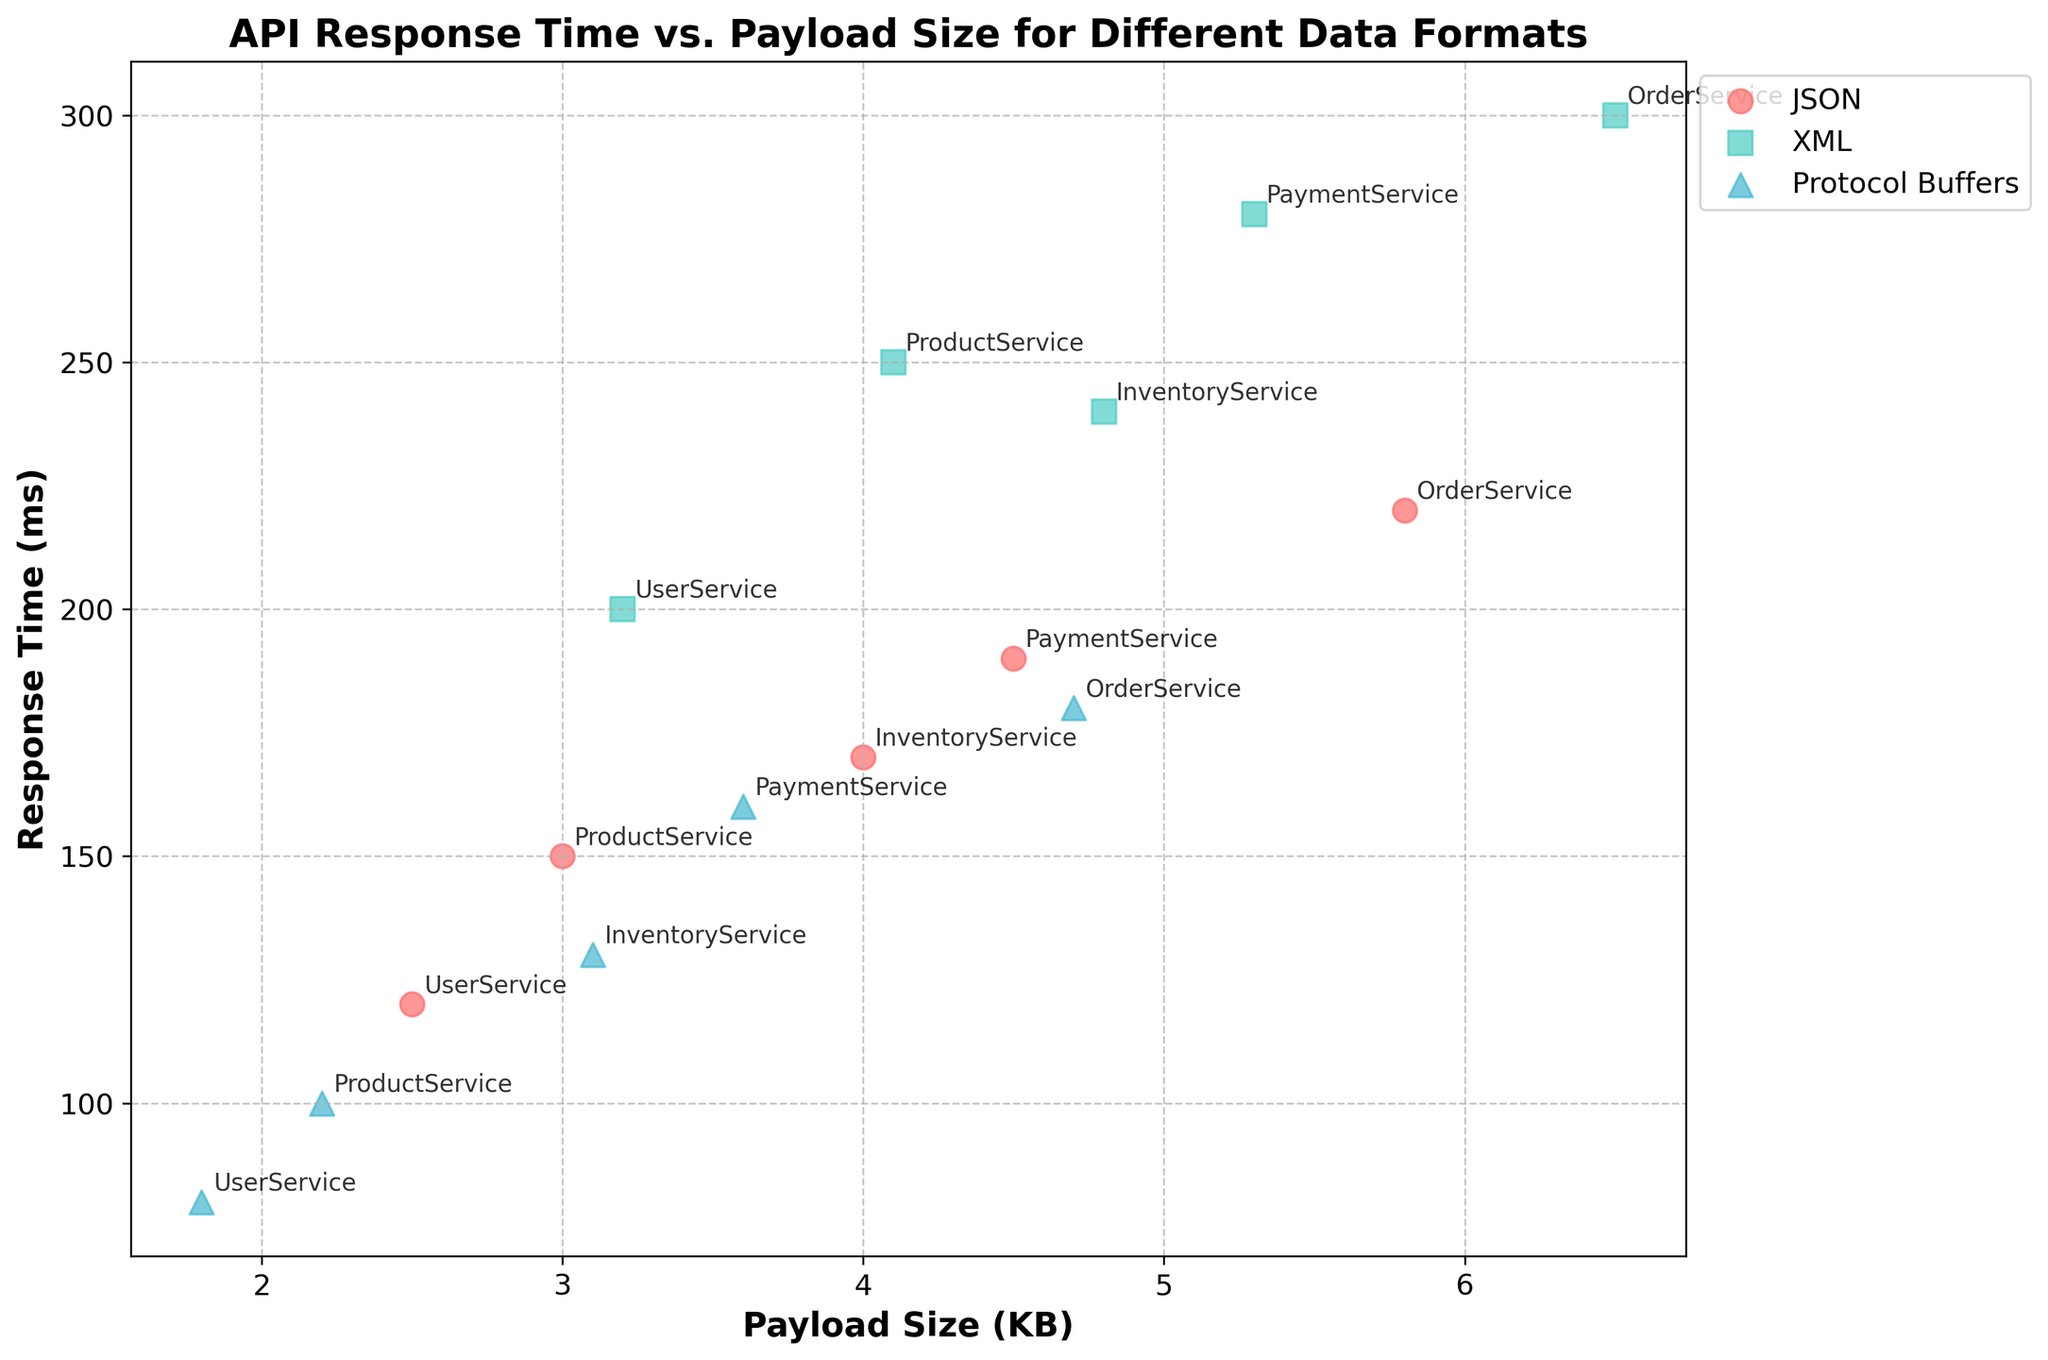What are the three different data formats represented in the figure? The legend in the figure indicates three different data formats represented by different colors and markers. These formats are JSON, XML, and Protocol Buffers.
Answer: JSON, XML, Protocol Buffers Which API has the smallest payload size for JSON format? Among the data points with the JSON format, the smallest payload size is located at UserService with a payload size of 2.5 KB.
Answer: UserService What is the trend between payload size and response time for each data format? By examining the scatter plot, we can observe the trend of response time as the payload size increases for each format. Generally, larger payload sizes correspond to higher response times, but this trend varies slightly across different data formats. JSON shows a noticeable increase, XML also increases with slightly steeper response times, and Protocol Buffers appear to have the least variation in response times.
Answer: Higher payload size tends to increase response time Which data format has the fastest response time for ProductService? The data points related to ProductService indicate that Protocol Buffers format has the fastest response time at 100 ms, which is lower than JSON (150 ms) and XML (250 ms).
Answer: Protocol Buffers How does the response time of OrderService compare to the other services when using XML format? For OrderService using XML format, the response time is 300 ms. This is the highest among the services when using the XML format as the other services' response times are 240 ms (InventoryService), 280 ms (PaymentService), and 200 ms (UserService).
Answer: Highest/Longer What is the difference in response time between JSON and Protocol Buffers for PaymentService? For PaymentService, the response time for JSON is 190 ms, and for Protocol Buffers, it is 160 ms. The difference between these times is 190 - 160 = 30 ms.
Answer: 30 ms Which combination of service and format has the largest payload size? From the scatterplot, the OrderService with the JSON format has the largest payload size at 5.8 KB.
Answer: OrderService, JSON If you average the payload size of all data points in the figure, what is the result? Adding all payload sizes: 2.5 + 3.2 + 1.8 + 3.0 + 4.1 + 2.2 + 5.8 + 6.5 + 4.7 + 4.0 + 4.8 + 3.1 + 4.5 + 5.3 + 3.6 = 58.1, with 15 data points, the average is 58.1 / 15 = 3.87 KB.
Answer: 3.87 KB Which service has the most consistent response times across the different formats? By comparing the response times for each format within each service, Protocol Buffers tend to have less variation, with the lowest range in response times. InventoryService has response times of 170 ms (JSON), 240 ms (XML), and 130 ms (Protocol Buffers), showing a relatively consistent response range.
Answer: InventoryService 